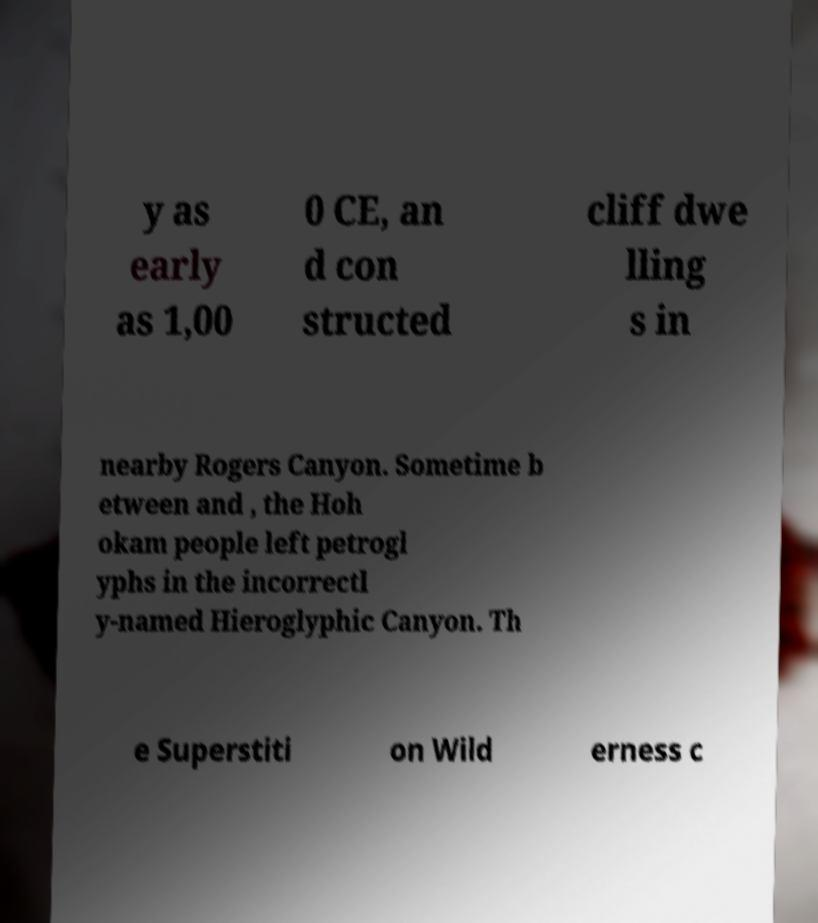Please identify and transcribe the text found in this image. y as early as 1,00 0 CE, an d con structed cliff dwe lling s in nearby Rogers Canyon. Sometime b etween and , the Hoh okam people left petrogl yphs in the incorrectl y-named Hieroglyphic Canyon. Th e Superstiti on Wild erness c 